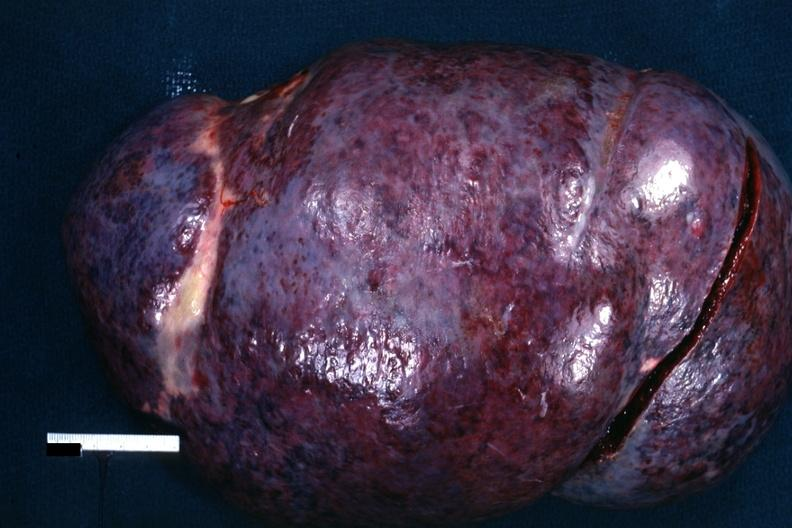what is present?
Answer the question using a single word or phrase. Chronic lymphocytic leukemia 